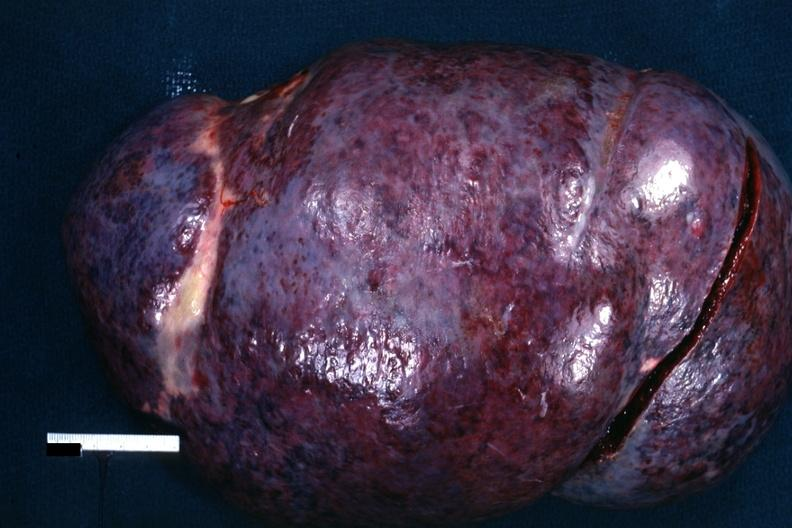what is present?
Answer the question using a single word or phrase. Chronic lymphocytic leukemia 